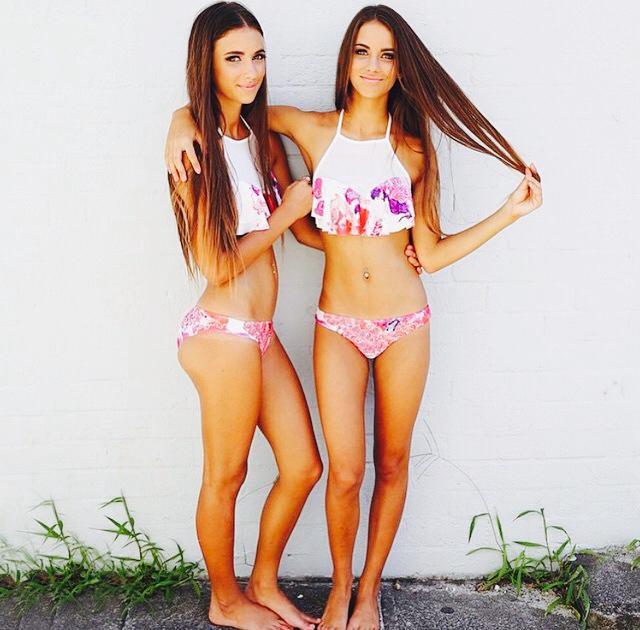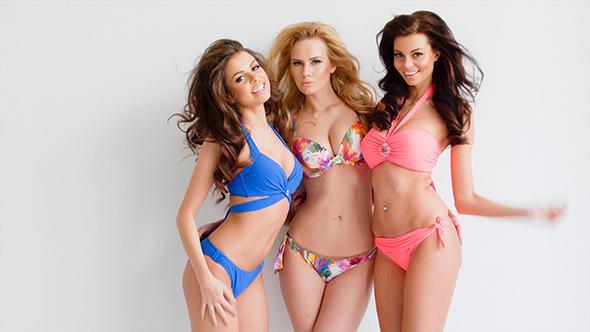The first image is the image on the left, the second image is the image on the right. Examine the images to the left and right. Is the description "There are six women wearing swimsuits." accurate? Answer yes or no. No. 